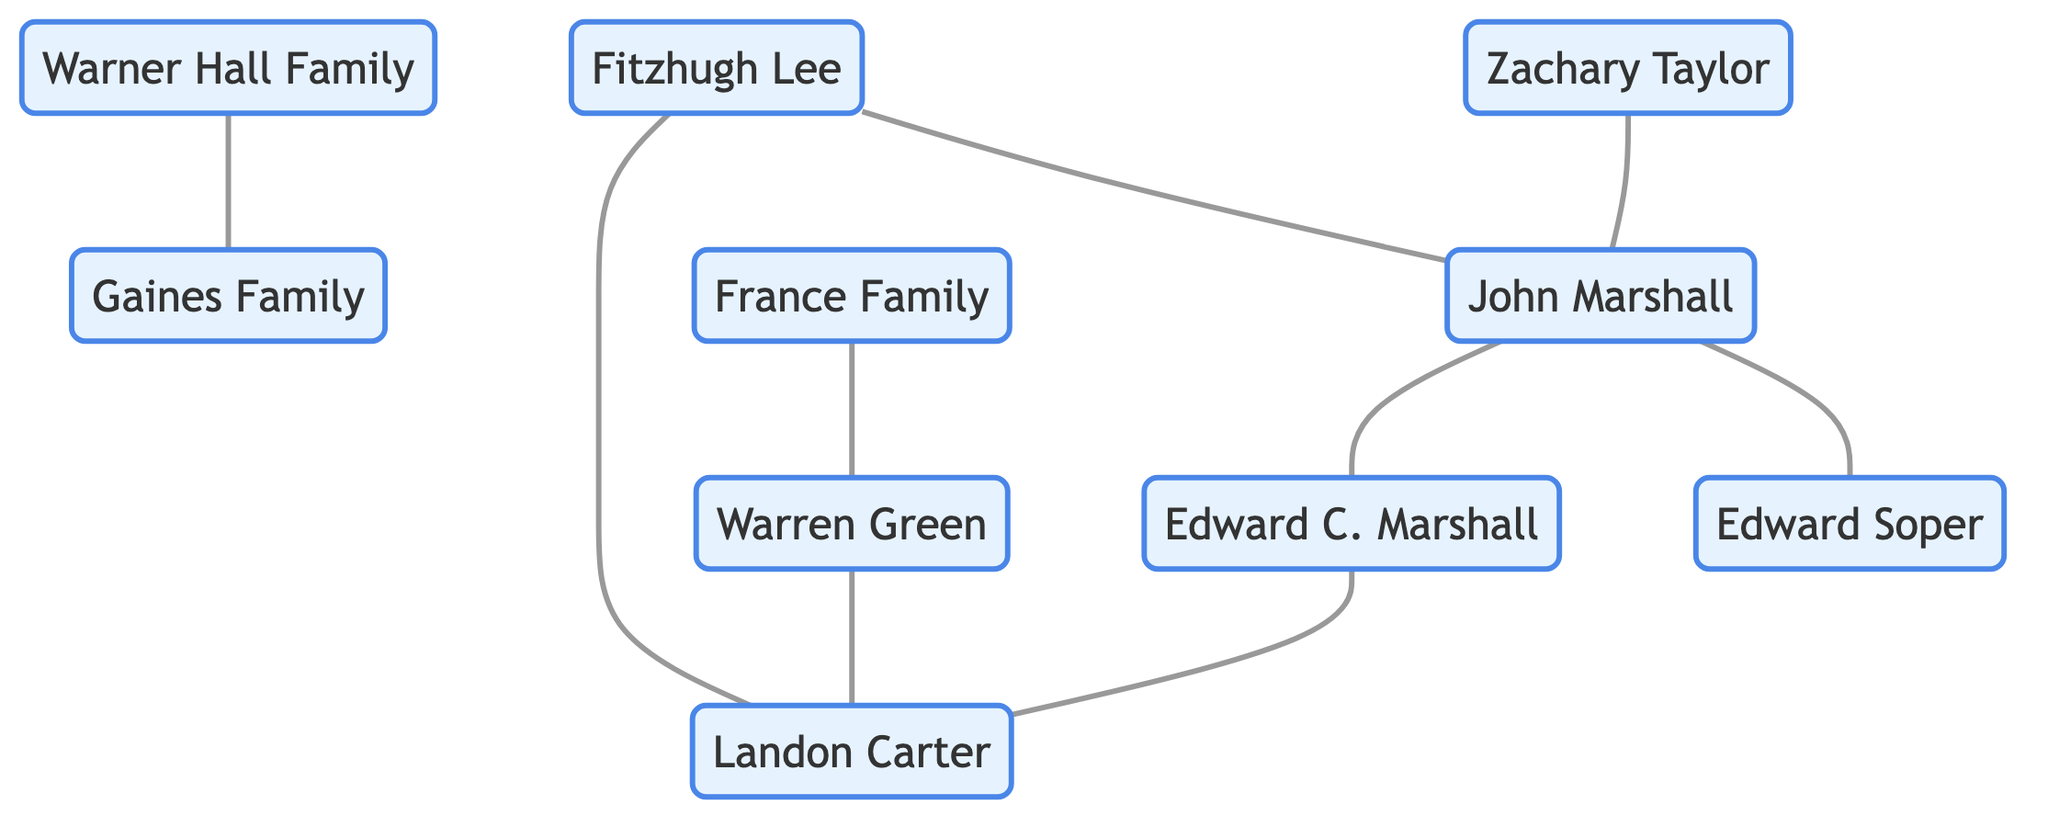What is the number of nodes in the diagram? By counting the unique individuals and families listed in the nodes, we can identify that there are 10 distinct nodes present.
Answer: 10 Who is the Chief Justice of the United States Supreme Court in this network? The node labeled "John Marshall" is designated as the Chief Justice of the United States Supreme Court, providing the required title.
Answer: John Marshall What relationship exists between John Marshall and Edward Carrington Marshall? The diagram indicates a direct line of connection between these two nodes, specifically labeled as "father-son," indicating their relationship.
Answer: father-son Which prominent figure is noted for being a legal mentor to John Marshall? The edge leading to the node "Fitzhugh Lee" describes him as a legal mentor for John Marshall within the graph.
Answer: Fitzhugh Lee What role does Warren Green play in relation to the Landon Carter? The diagram establishes a relationship between Warren Green and Landon Carter, specifically indicating that Warren hosted many gatherings for Landon Carter.
Answer: hosted many gatherings How many distinct types of relationships do we see in the diagram? By reviewing the edges and their descriptions, we note that there are three distinct types of relationships: familial, political, and business partnerships.
Answer: 3 Which family is indicated as politically allied with Edward Carrington Marshall? The edge indicated in the diagram shows that Landon Carter is the political ally associated with Edward Carrington Marshall.
Answer: Landon Carter Who is a Revolutionary War hero represented in the graph? The diagram contains a node labeled "Edward Soper," explicitly designating him as a Revolutionary War hero.
Answer: Edward Soper Which family is noted as neighboring and politically allied with the Warner Hall Family? The relationship between the Warner Hall Family and the Gaines Family is established as neighboring and politically allied, as shown in the diagram.
Answer: Gaines Family 